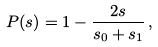Convert formula to latex. <formula><loc_0><loc_0><loc_500><loc_500>P ( s ) = 1 - \frac { 2 s } { s _ { 0 } + s _ { 1 } } \, ,</formula> 